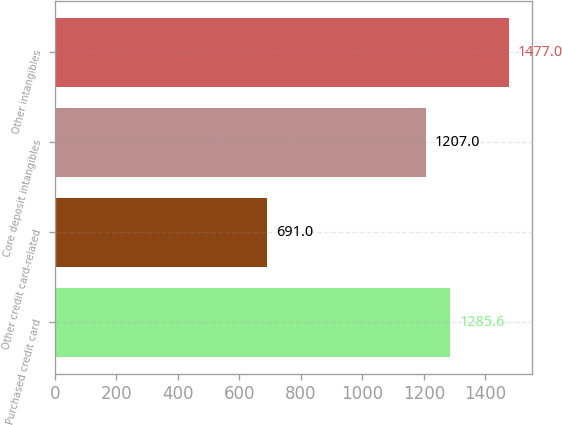<chart> <loc_0><loc_0><loc_500><loc_500><bar_chart><fcel>Purchased credit card<fcel>Other credit card-related<fcel>Core deposit intangibles<fcel>Other intangibles<nl><fcel>1285.6<fcel>691<fcel>1207<fcel>1477<nl></chart> 